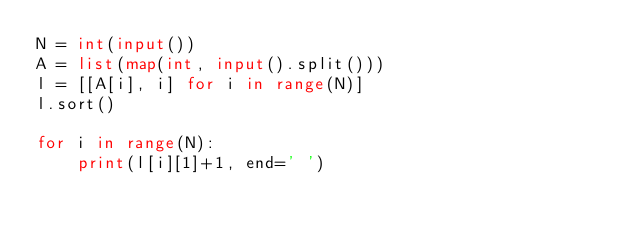<code> <loc_0><loc_0><loc_500><loc_500><_Python_>N = int(input())
A = list(map(int, input().split()))
l = [[A[i], i] for i in range(N)]
l.sort()

for i in range(N):
    print(l[i][1]+1, end=' ')</code> 